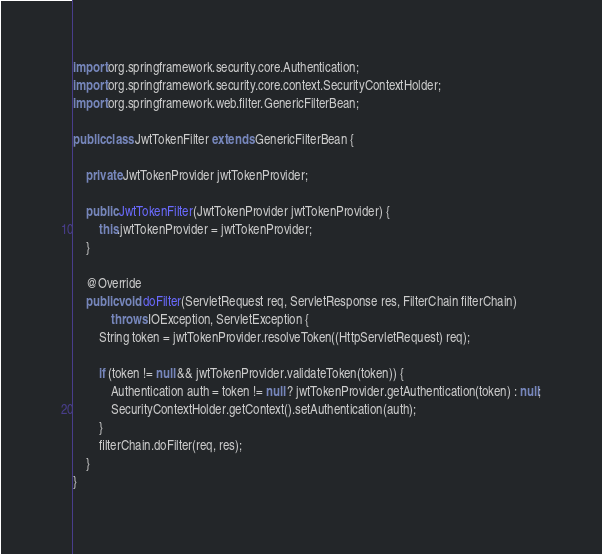Convert code to text. <code><loc_0><loc_0><loc_500><loc_500><_Java_>
import org.springframework.security.core.Authentication;
import org.springframework.security.core.context.SecurityContextHolder;
import org.springframework.web.filter.GenericFilterBean;

public class JwtTokenFilter extends GenericFilterBean {

    private JwtTokenProvider jwtTokenProvider;

    public JwtTokenFilter(JwtTokenProvider jwtTokenProvider) {
        this.jwtTokenProvider = jwtTokenProvider;
    }

    @Override
    public void doFilter(ServletRequest req, ServletResponse res, FilterChain filterChain)
            throws IOException, ServletException {
        String token = jwtTokenProvider.resolveToken((HttpServletRequest) req);

        if (token != null && jwtTokenProvider.validateToken(token)) {
            Authentication auth = token != null ? jwtTokenProvider.getAuthentication(token) : null;
            SecurityContextHolder.getContext().setAuthentication(auth);
        }
        filterChain.doFilter(req, res);
    }
}</code> 